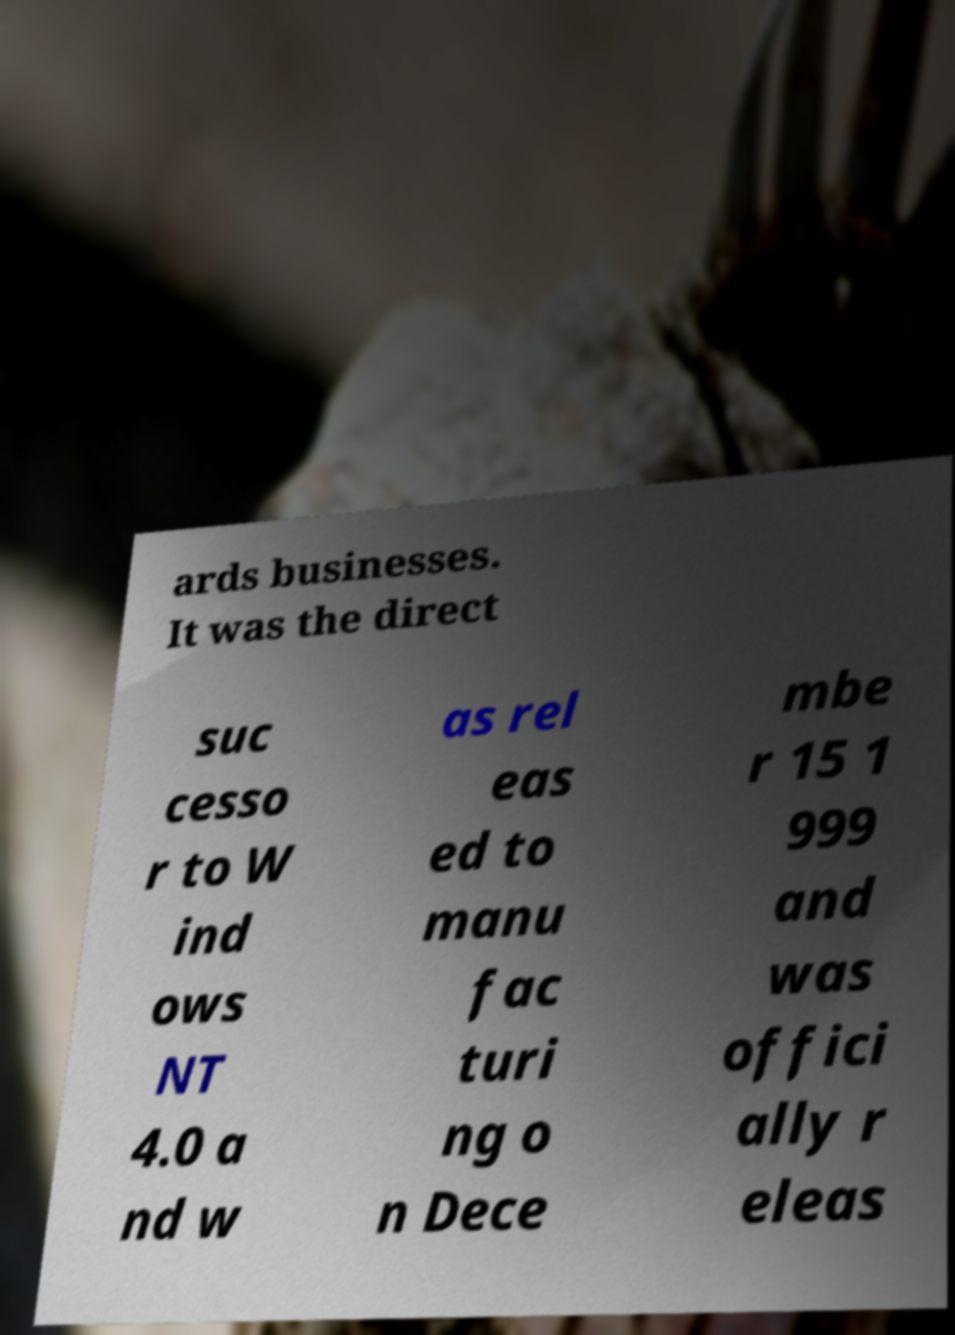For documentation purposes, I need the text within this image transcribed. Could you provide that? ards businesses. It was the direct suc cesso r to W ind ows NT 4.0 a nd w as rel eas ed to manu fac turi ng o n Dece mbe r 15 1 999 and was offici ally r eleas 